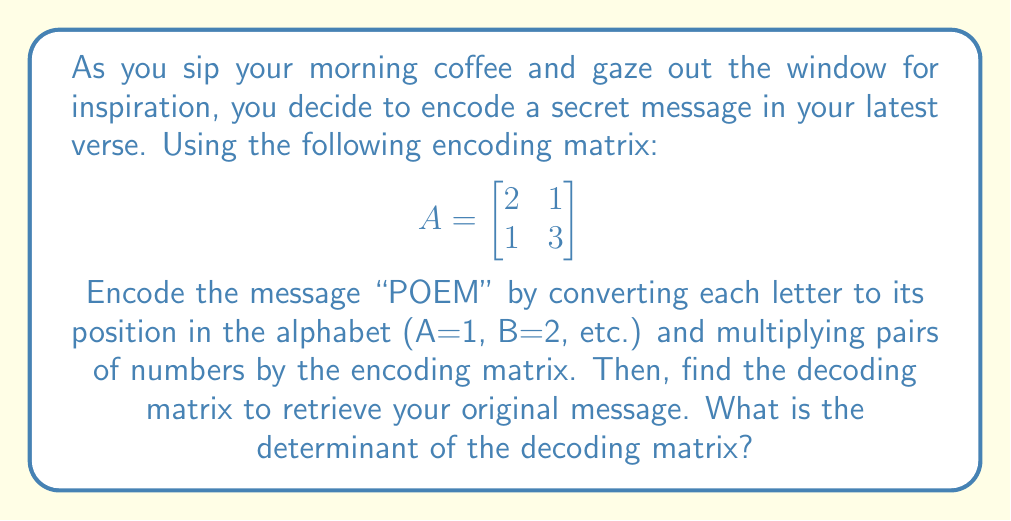Could you help me with this problem? 1) First, convert "POEM" to numbers:
   P=16, O=15, E=5, M=13

2) Group the numbers in pairs: (16,15) and (5,13)

3) Encode each pair using matrix multiplication:
   For (16,15): 
   $$\begin{bmatrix}
   2 & 1 \\
   1 & 3
   \end{bmatrix} \begin{bmatrix}
   16 \\
   15
   \end{bmatrix} = \begin{bmatrix}
   2(16) + 1(15) \\
   1(16) + 3(15)
   \end{bmatrix} = \begin{bmatrix}
   47 \\
   61
   \end{bmatrix}$$

   For (5,13):
   $$\begin{bmatrix}
   2 & 1 \\
   1 & 3
   \end{bmatrix} \begin{bmatrix}
   5 \\
   13
   \end{bmatrix} = \begin{bmatrix}
   2(5) + 1(13) \\
   1(5) + 3(13)
   \end{bmatrix} = \begin{bmatrix}
   23 \\
   44
   \end{bmatrix}$$

4) To decode, we need the inverse of A. The inverse exists if det(A) ≠ 0.
   $det(A) = (2)(3) - (1)(1) = 6 - 1 = 5$

5) The inverse of A is:
   $$A^{-1} = \frac{1}{det(A)} \begin{bmatrix}
   3 & -1 \\
   -1 & 2
   \end{bmatrix} = \frac{1}{5} \begin{bmatrix}
   3 & -1 \\
   -1 & 2
   \end{bmatrix}$$

6) The determinant of the decoding matrix $A^{-1}$ is:
   $det(A^{-1}) = \frac{1}{det(A)} = \frac{1}{5}$
Answer: $\frac{1}{5}$ 